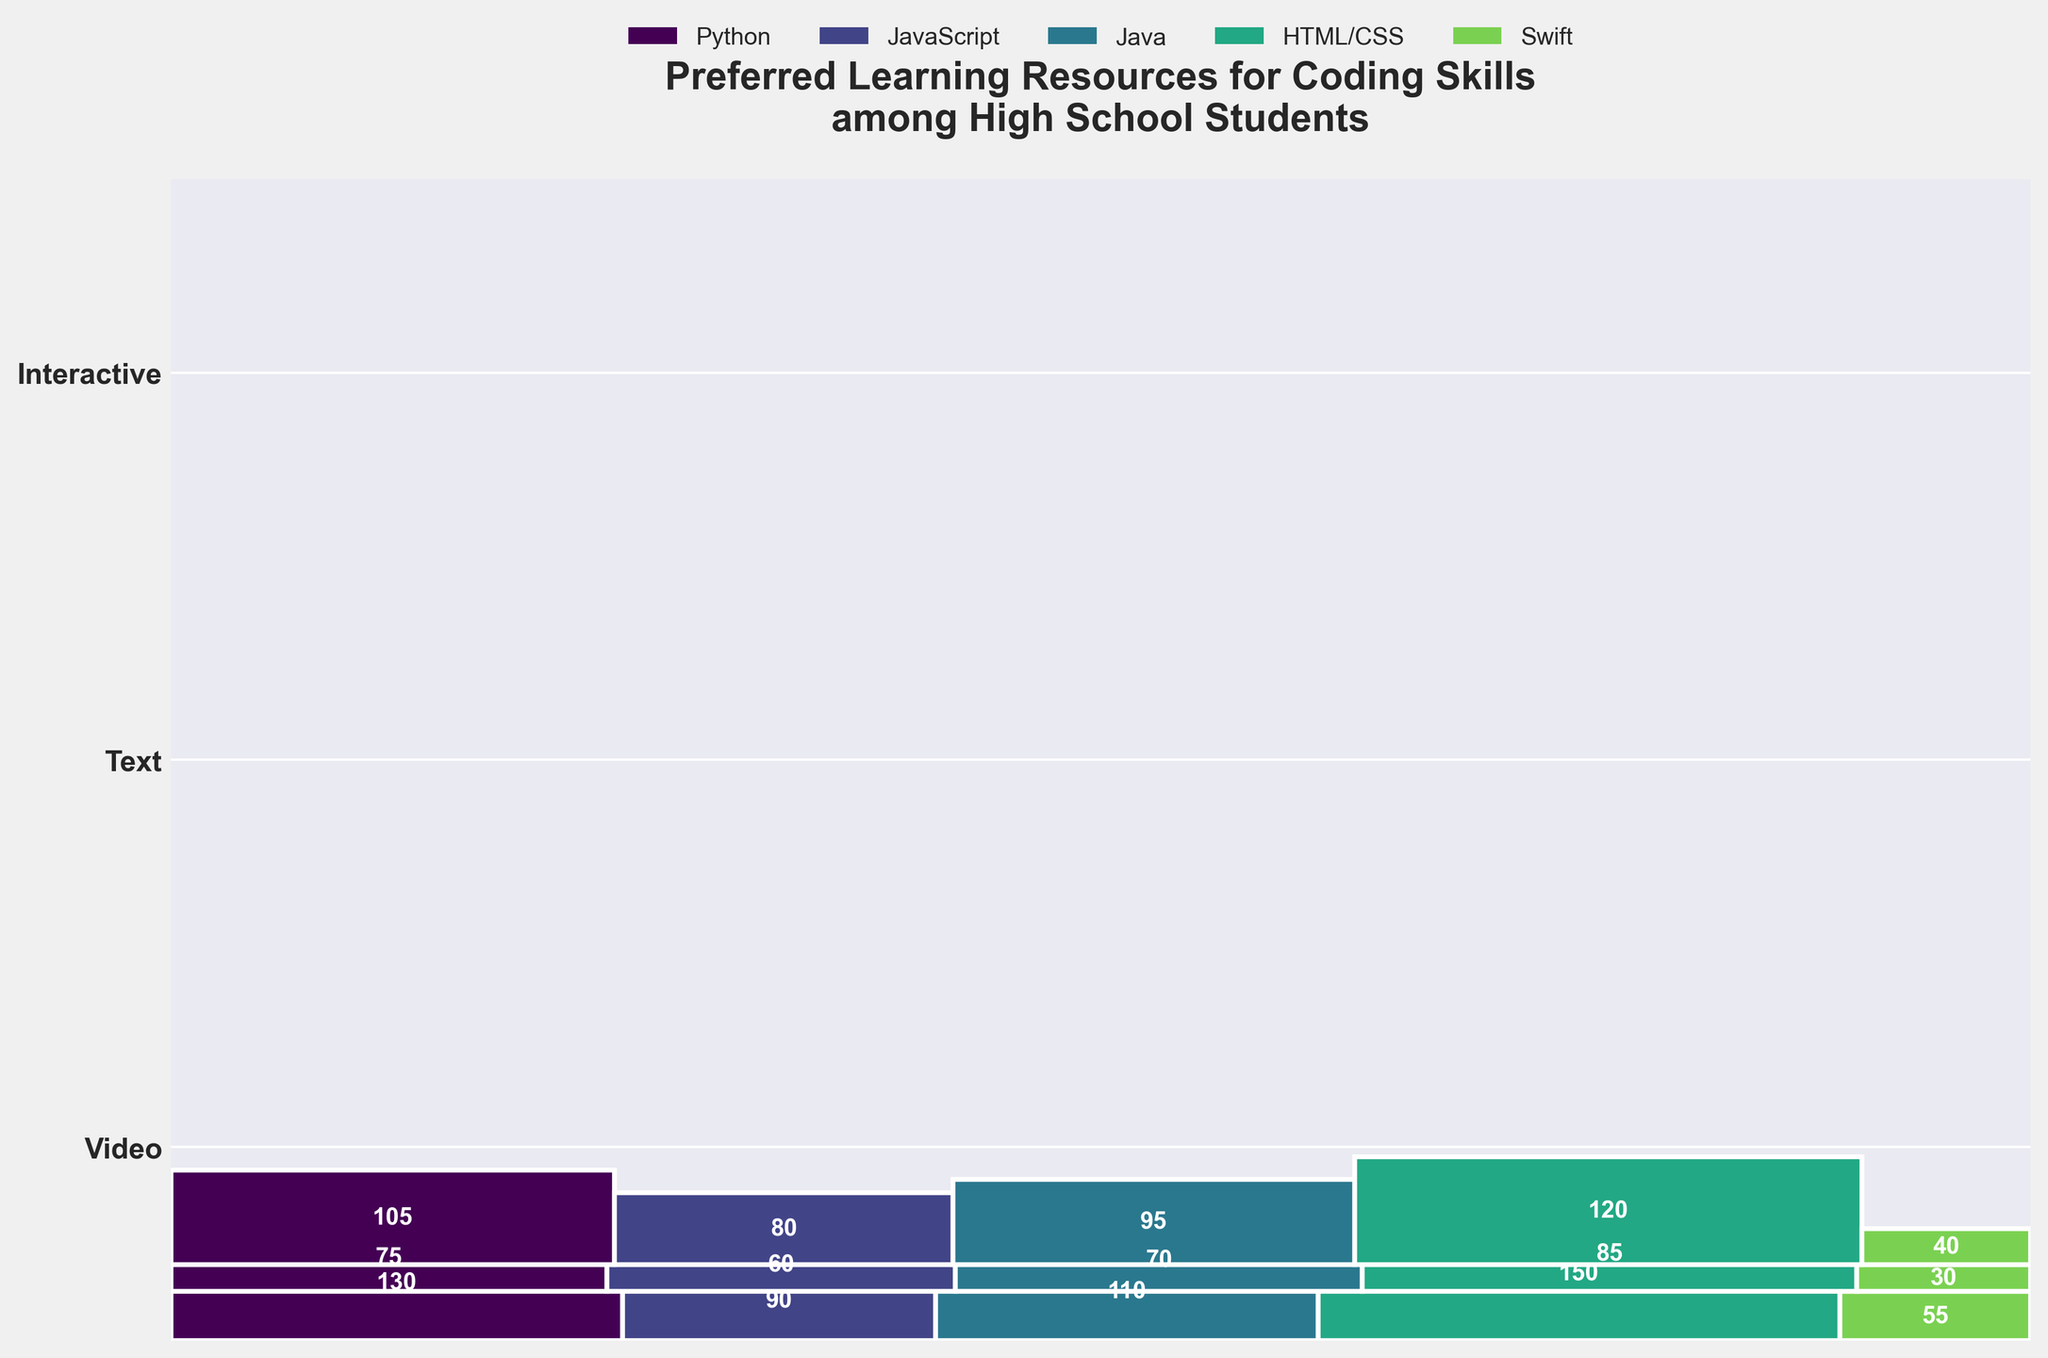What is the most preferred learning format for Python? The heights of the rectangles represent the counts. The tallest rectangle under "Python" indicates the most preferred format. The "Interactive" format for Python has the greatest height.
Answer: Interactive Which format has the least preference for learning Swift? By looking at the relative heights of the rectangles under "Swift," the "Text" format clearly has the smallest height.
Answer: Text Compare the preference for interactive formats between Python and Java. Which is higher? Look at the heights of the rectangles under "Interactive" for both Python and Java. The "Interactive" format for Python is taller than for Java.
Answer: Python What is the total number of students who prefer video resources? Add the counts for all subjects under the "Video" format: 120 (Python) + 95 (JavaScript) + 80 (Java) + 105 (HTML/CSS) + 40 (Swift) = 440.
Answer: 440 How many more students prefer text formats for HTML/CSS compared to Swift? Find the counts for HTML/CSS and Swift under "Text" and subtract them: 75 (HTML/CSS) - 30 (Swift) = 45.
Answer: 45 What is the ratio of students preferring interactive formats to text formats for learning JavaScript? Divide the count of students for the "Interactive" format by the count of students for the "Text" format for JavaScript: 110 (Interactive) / 70 (Text) = 1.57.
Answer: 1.57 Which subject has the least preference in interactive formats? Identify the smallest rectangle in the "Interactive" format row. The rectangle for "Swift" has the smallest height.
Answer: Swift 